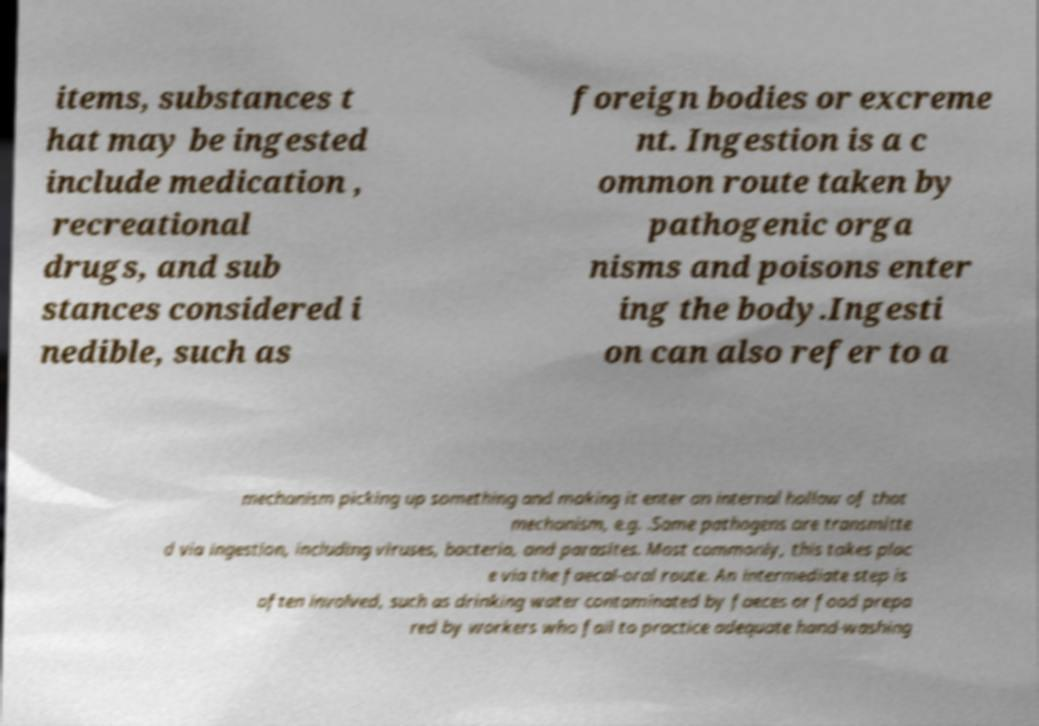Could you assist in decoding the text presented in this image and type it out clearly? items, substances t hat may be ingested include medication , recreational drugs, and sub stances considered i nedible, such as foreign bodies or excreme nt. Ingestion is a c ommon route taken by pathogenic orga nisms and poisons enter ing the body.Ingesti on can also refer to a mechanism picking up something and making it enter an internal hollow of that mechanism, e.g. .Some pathogens are transmitte d via ingestion, including viruses, bacteria, and parasites. Most commonly, this takes plac e via the faecal-oral route. An intermediate step is often involved, such as drinking water contaminated by faeces or food prepa red by workers who fail to practice adequate hand-washing 